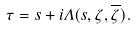<formula> <loc_0><loc_0><loc_500><loc_500>\tau = s + i \Lambda ( s , \zeta , \overline { \zeta } ) .</formula> 